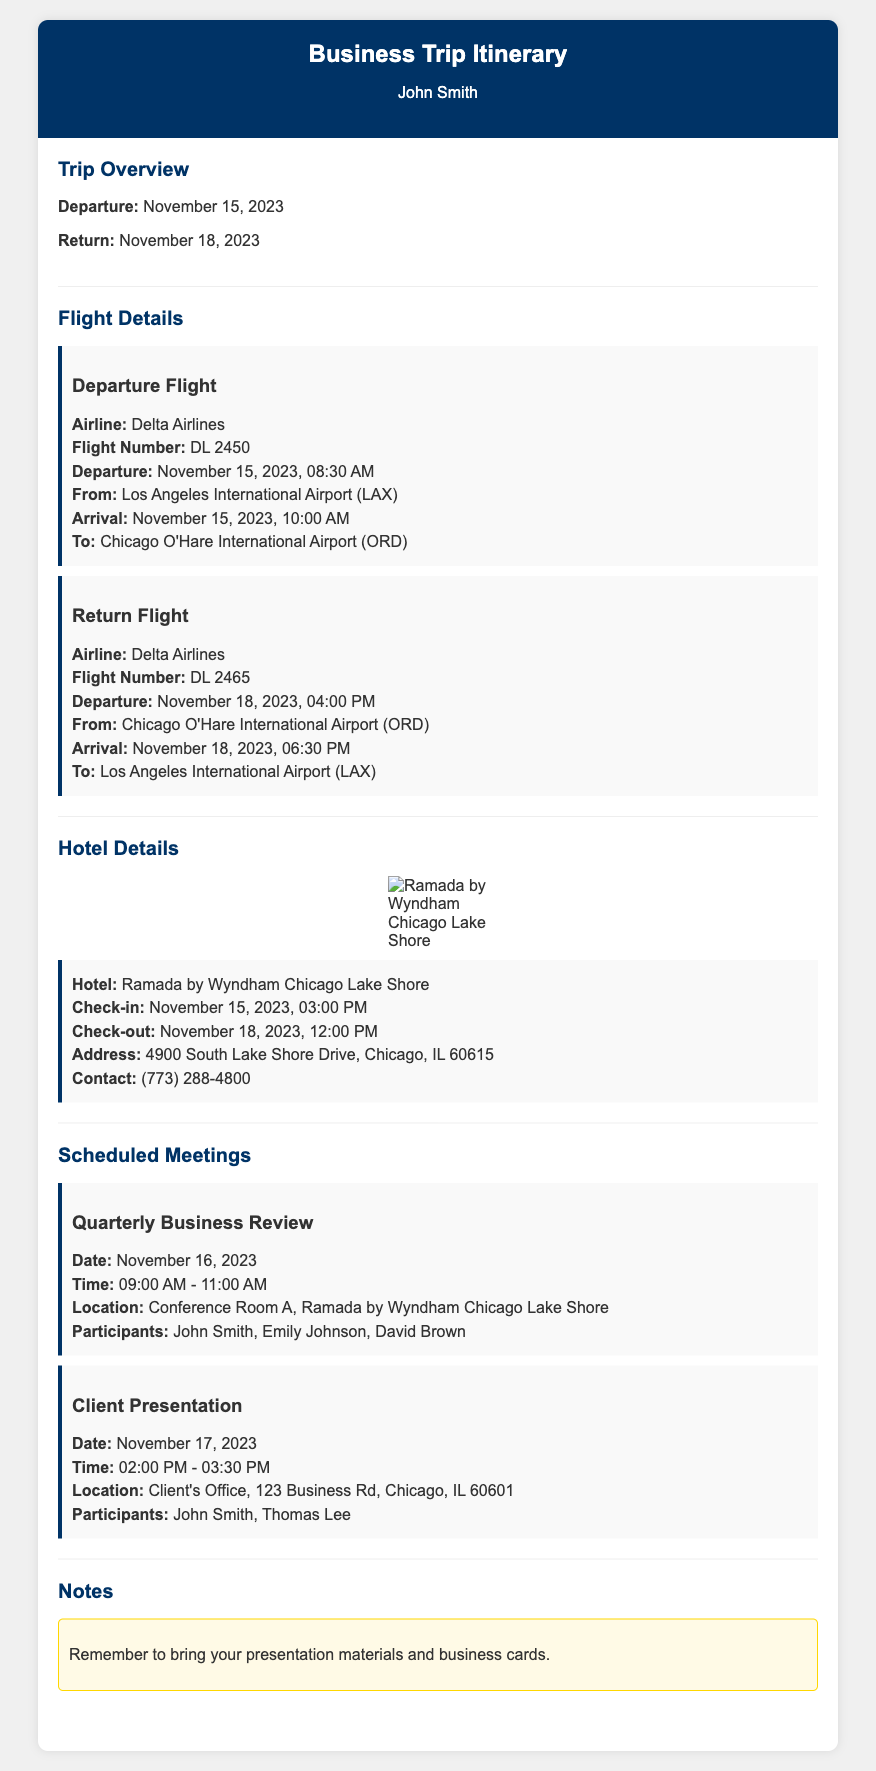What is the departure date for the trip? The departure date is clearly stated in the Trip Overview section of the document.
Answer: November 15, 2023 What time is the hotel check-in? The hotel check-in time is provided in the Hotel Details section, which specifies the time for check-in.
Answer: 03:00 PM Who is participating in the Quarterly Business Review? The participants for the meeting are listed in the Meeting Details section under the specific meeting.
Answer: John Smith, Emily Johnson, David Brown What is the location of the Client Presentation? The location is mentioned in the Meeting Details section for the meeting on November 17, 2023.
Answer: Client's Office, 123 Business Rd, Chicago, IL 60601 What is the flight number for the return flight? The flight number is found in the Flight Details section for the return flight, which includes all pertinent details.
Answer: DL 2465 What is the check-out time for the hotel? The check-out time is specified in the Hotel Details section alongside check-in details.
Answer: 12:00 PM When is the Quarterly Business Review scheduled? The date for the meeting is provided in the Meeting Details section and is essential for planning.
Answer: November 16, 2023 Which airline is providing the flights? The airline name is mentioned in the Flight Details section for both the departure and return flights.
Answer: Delta Airlines 